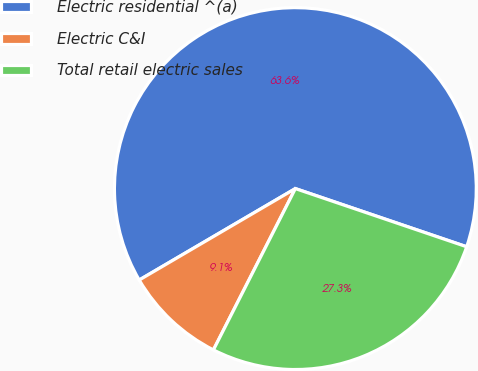Convert chart. <chart><loc_0><loc_0><loc_500><loc_500><pie_chart><fcel>Electric residential ^(a)<fcel>Electric C&I<fcel>Total retail electric sales<nl><fcel>63.64%<fcel>9.09%<fcel>27.27%<nl></chart> 